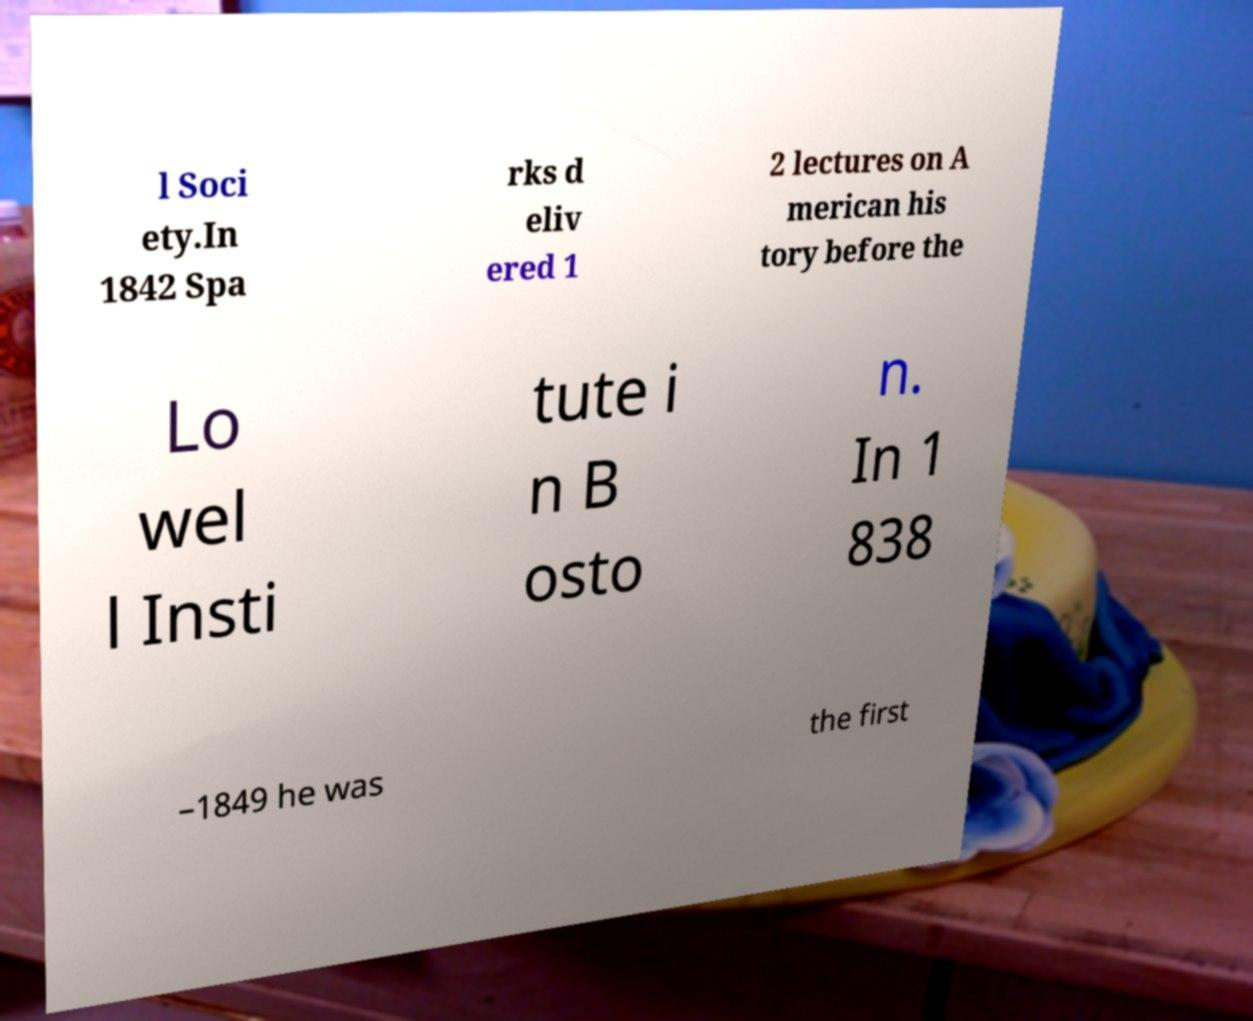Can you accurately transcribe the text from the provided image for me? l Soci ety.In 1842 Spa rks d eliv ered 1 2 lectures on A merican his tory before the Lo wel l Insti tute i n B osto n. In 1 838 –1849 he was the first 